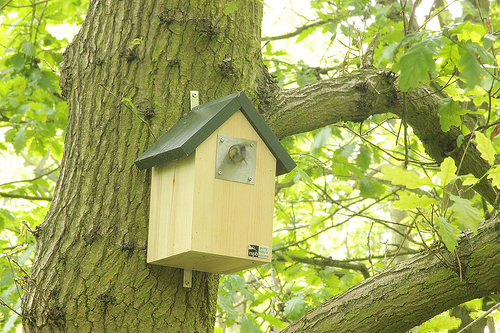<image>
Is the box next to the tree? No. The box is not positioned next to the tree. They are located in different areas of the scene. 